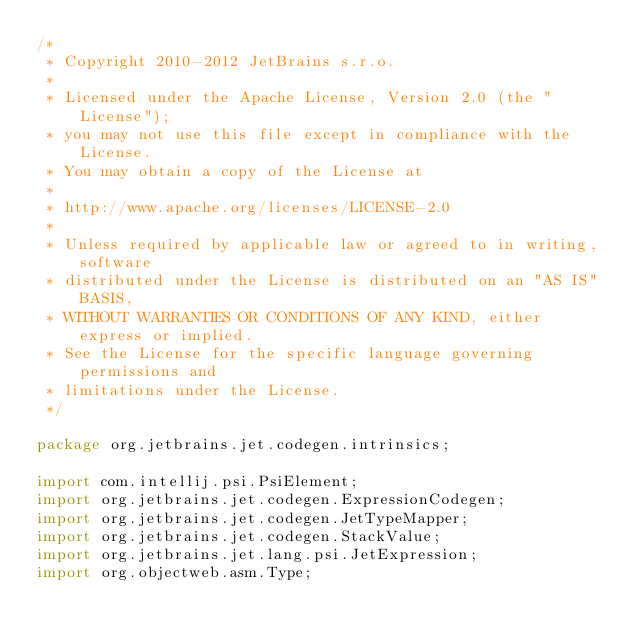<code> <loc_0><loc_0><loc_500><loc_500><_Java_>/*
 * Copyright 2010-2012 JetBrains s.r.o.
 *
 * Licensed under the Apache License, Version 2.0 (the "License");
 * you may not use this file except in compliance with the License.
 * You may obtain a copy of the License at
 *
 * http://www.apache.org/licenses/LICENSE-2.0
 *
 * Unless required by applicable law or agreed to in writing, software
 * distributed under the License is distributed on an "AS IS" BASIS,
 * WITHOUT WARRANTIES OR CONDITIONS OF ANY KIND, either express or implied.
 * See the License for the specific language governing permissions and
 * limitations under the License.
 */

package org.jetbrains.jet.codegen.intrinsics;

import com.intellij.psi.PsiElement;
import org.jetbrains.jet.codegen.ExpressionCodegen;
import org.jetbrains.jet.codegen.JetTypeMapper;
import org.jetbrains.jet.codegen.StackValue;
import org.jetbrains.jet.lang.psi.JetExpression;
import org.objectweb.asm.Type;</code> 